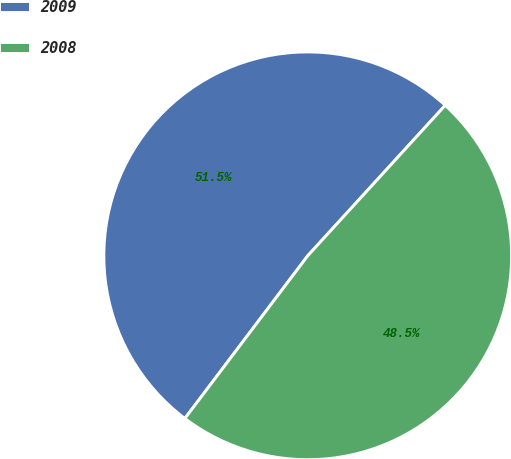<chart> <loc_0><loc_0><loc_500><loc_500><pie_chart><fcel>2009<fcel>2008<nl><fcel>51.49%<fcel>48.51%<nl></chart> 